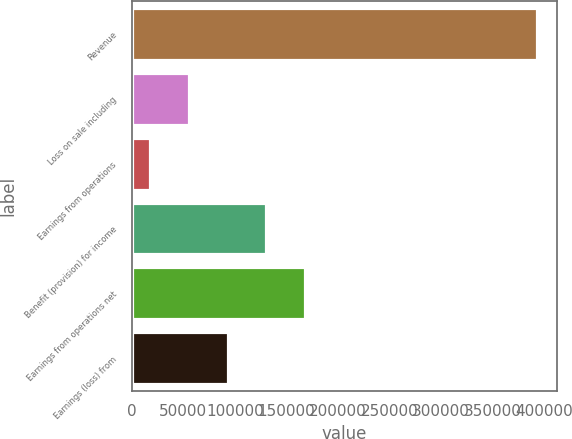<chart> <loc_0><loc_0><loc_500><loc_500><bar_chart><fcel>Revenue<fcel>Loss on sale including<fcel>Earnings from operations<fcel>Benefit (provision) for income<fcel>Earnings from operations net<fcel>Earnings (loss) from<nl><fcel>393184<fcel>55398.7<fcel>17867<fcel>130462<fcel>167994<fcel>92930.4<nl></chart> 